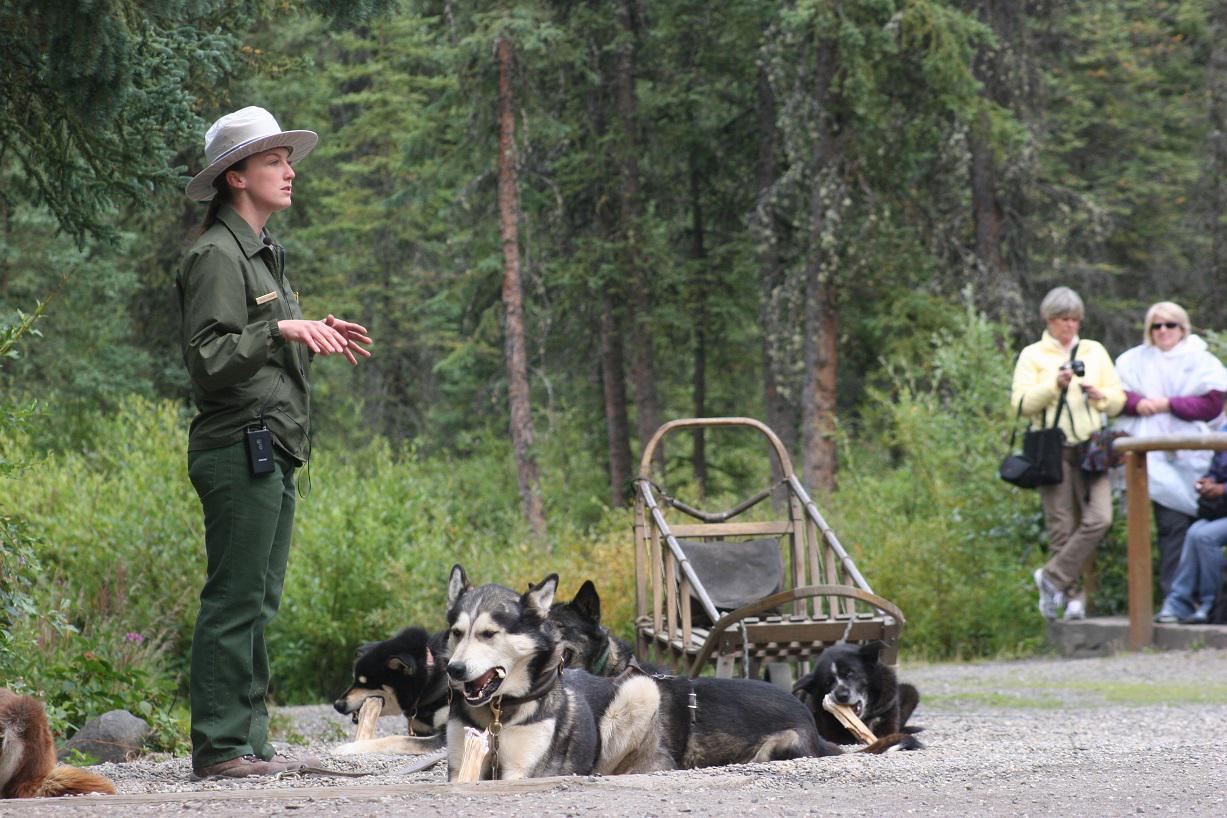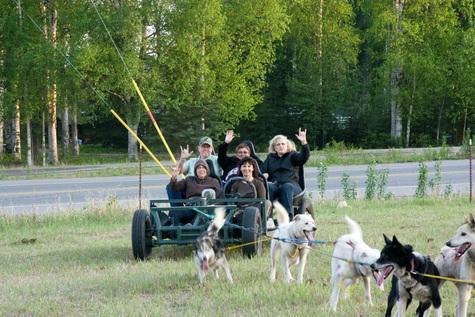The first image is the image on the left, the second image is the image on the right. For the images shown, is this caption "One of the sleds features a single rider." true? Answer yes or no. No. The first image is the image on the left, the second image is the image on the right. Assess this claim about the two images: "One image shows a team of dogs pulling a brown sled down an unpaved path, and the other image shows a team of dogs pulling a wheeled cart with passengers along a dirt road.". Correct or not? Answer yes or no. No. 